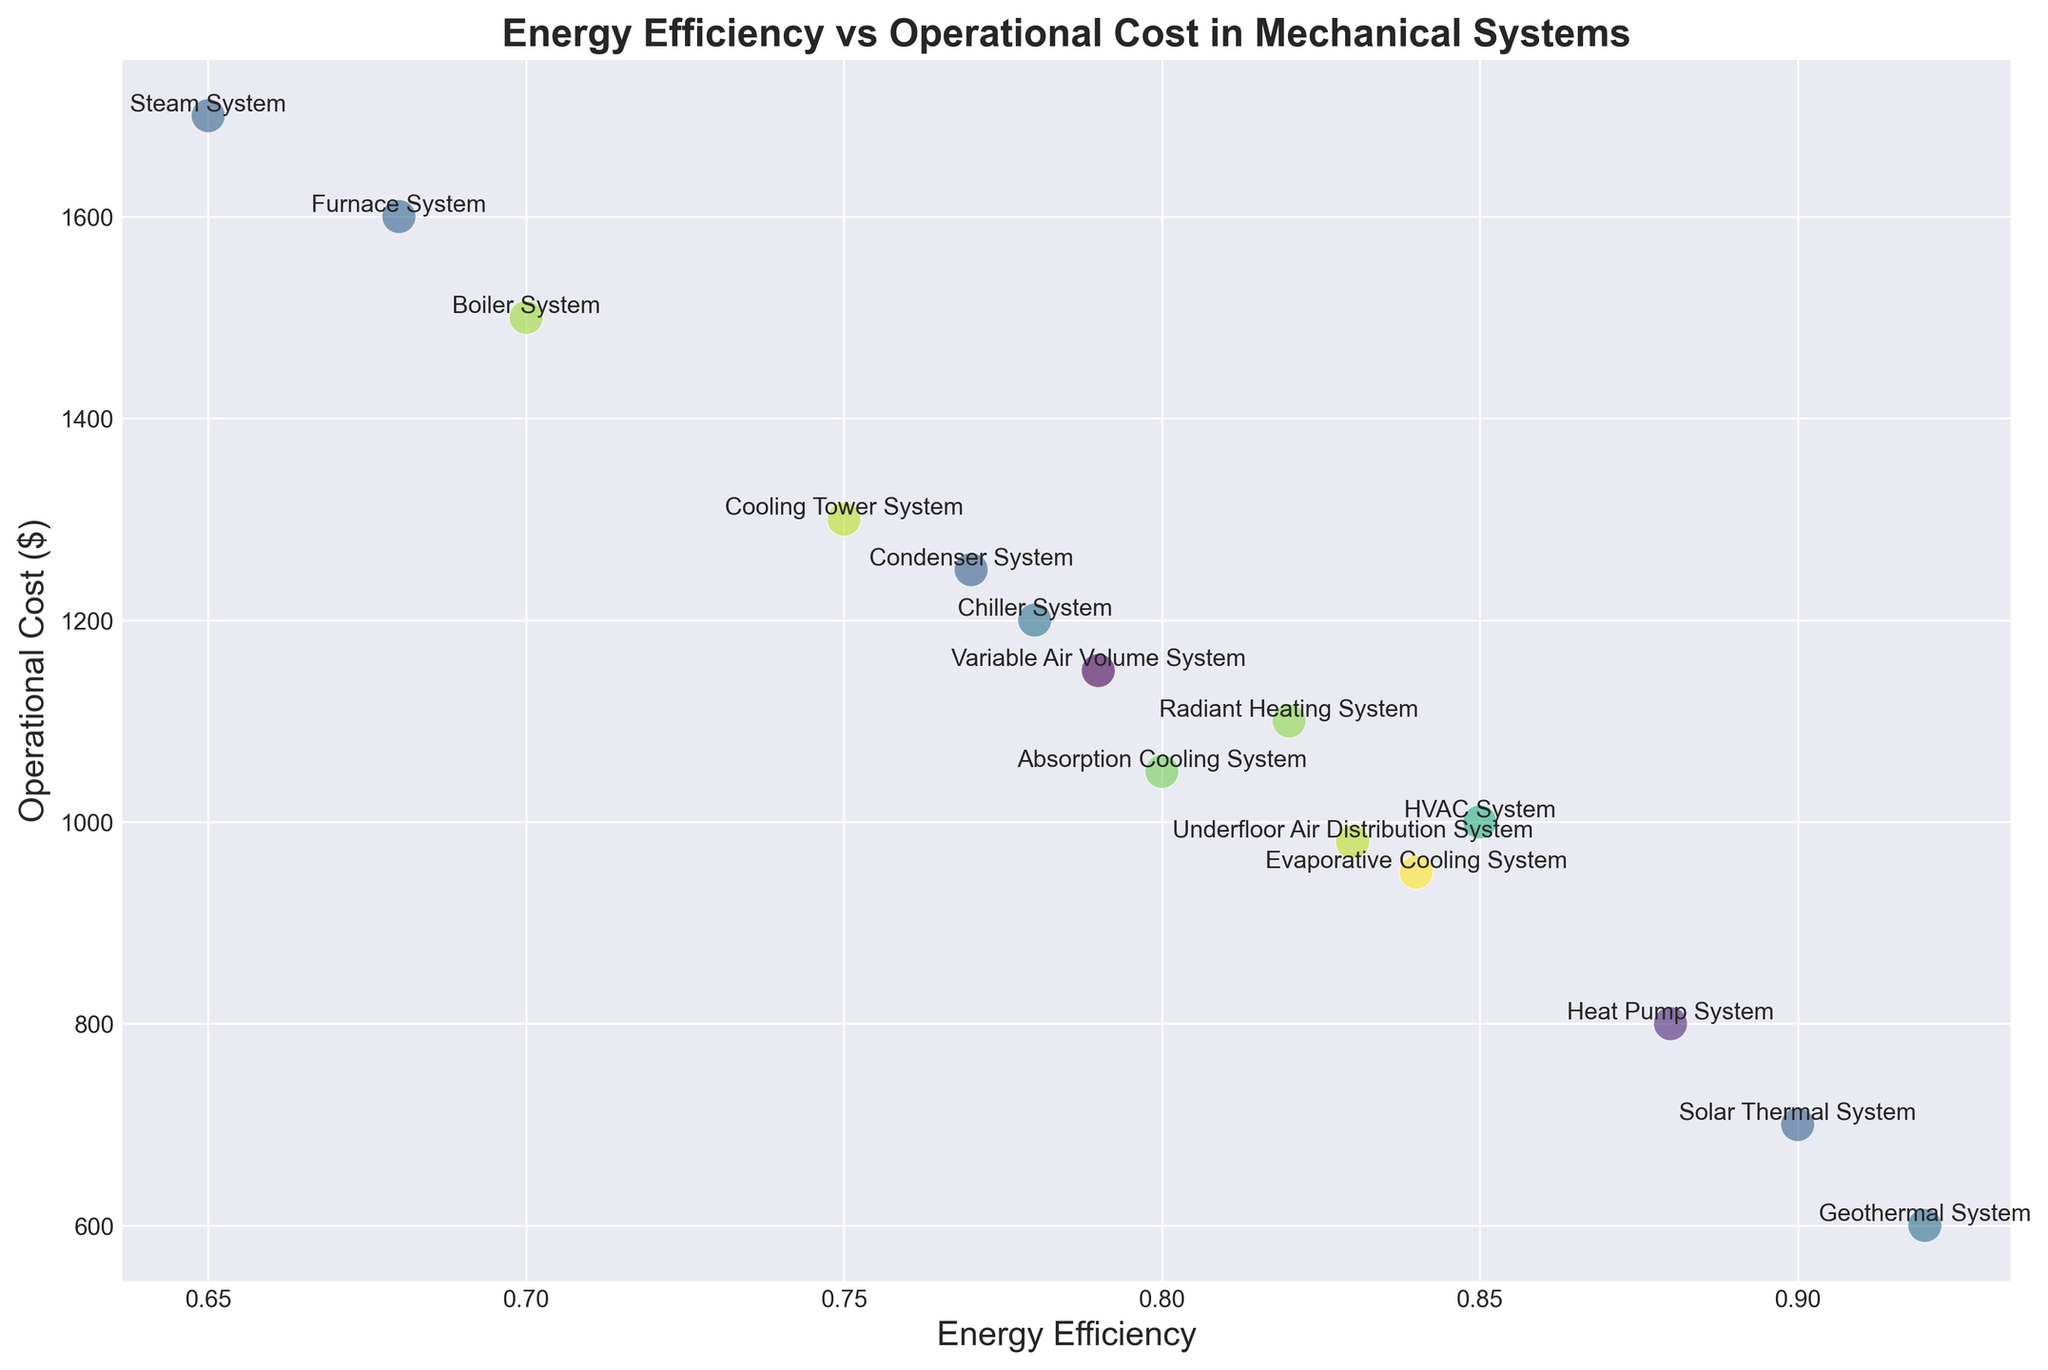What type of mechanical system has the highest operational cost? The system with the highest operational cost is identified by looking at the data point that is vertically highest on the y-axis (Operational Cost). The Steam System is at $1700 which is the highest.
Answer: Steam System Which system has the lowest energy efficiency, and what is its operational cost? The system with the lowest energy efficiency is found by identifying the leftmost data point along the x-axis (Energy Efficiency). The Steam System has an energy efficiency of 0.65, and its operational cost is $1700.
Answer: Steam System, $1700 Comparing the HVAC System and the Geothermal System, which one has a higher energy efficiency and by how much? First, locate the HVAC System and Geothermal System on the plot. The HVAC System has an energy efficiency of 0.85, and the Geothermal System has an energy efficiency of 0.92. The difference is 0.92 - 0.85 = 0.07.
Answer: Geothermal System, by 0.07 What is the difference in operational costs between the Solar Thermal System and the Chiller System? The operational costs can be seen on the y-axis. The Solar Thermal System has an operational cost of $700, and the Chiller System has an operational cost of $1200. The difference is $1200 - $700 = $500.
Answer: $500 Which system offers the highest energy efficiency and what is its corresponding operational cost? The system with the highest energy efficiency is identified by locating the rightmost data point along the x-axis. The Geothermal System has an energy efficiency of 0.92, and its operational cost is $600.
Answer: Geothermal System, $600 Between the Evaporative Cooling System and the Condenser System, which has a lower operational cost? The operational cost is determined by checking the y-axis values for both systems. The Evaporative Cooling System has an operational cost of $950, and the Condenser System has a cost of $1250. The Evaporative Cooling System has the lower cost.
Answer: Evaporative Cooling System What is the average operational cost of the systems with an energy efficiency greater than 0.8? First, identify the systems with energy efficiency greater than 0.8 which are HVAC System, Heat Pump System, Radiant Heating System, Solar Thermal System, Geothermal System, Absorption Cooling System, Evaporative Cooling System, Underfloor Air Distribution System. Sum their operational costs: 1000 + 800 + 1100 + 700 + 600 + 1050 + 950 + 980 = 7180. Then, divide by the number of systems: 7180 / 8 = $897.50
Answer: $897.50 Which type of cooling system has the highest energy efficiency? From the plot, identify the cooling systems (e.g., Chiller System, Cooling Tower System, etc.) and compare their energy efficiencies. The Cooling System with the highest energy efficiency is the Evaporative Cooling System with an efficiency of 0.84.
Answer: Evaporative Cooling System Considering only heating systems, which has the lowest operational cost? Heating systems include Boiler, Furnace, Radiant Heating, and others. Compare their operational costs: Boiler System ($1500), Furnace System ($1600), Radiant Heating System ($1100). The Radiant Heating System has the lowest operational cost of $1100.
Answer: Radiant Heating System 